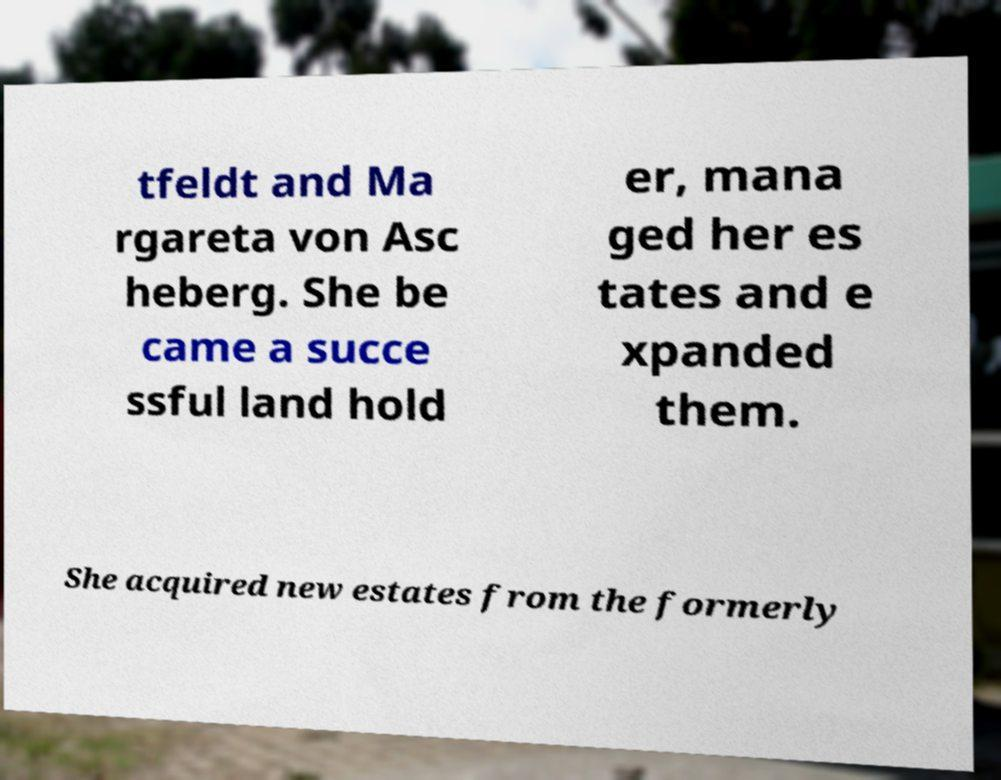Could you assist in decoding the text presented in this image and type it out clearly? tfeldt and Ma rgareta von Asc heberg. She be came a succe ssful land hold er, mana ged her es tates and e xpanded them. She acquired new estates from the formerly 